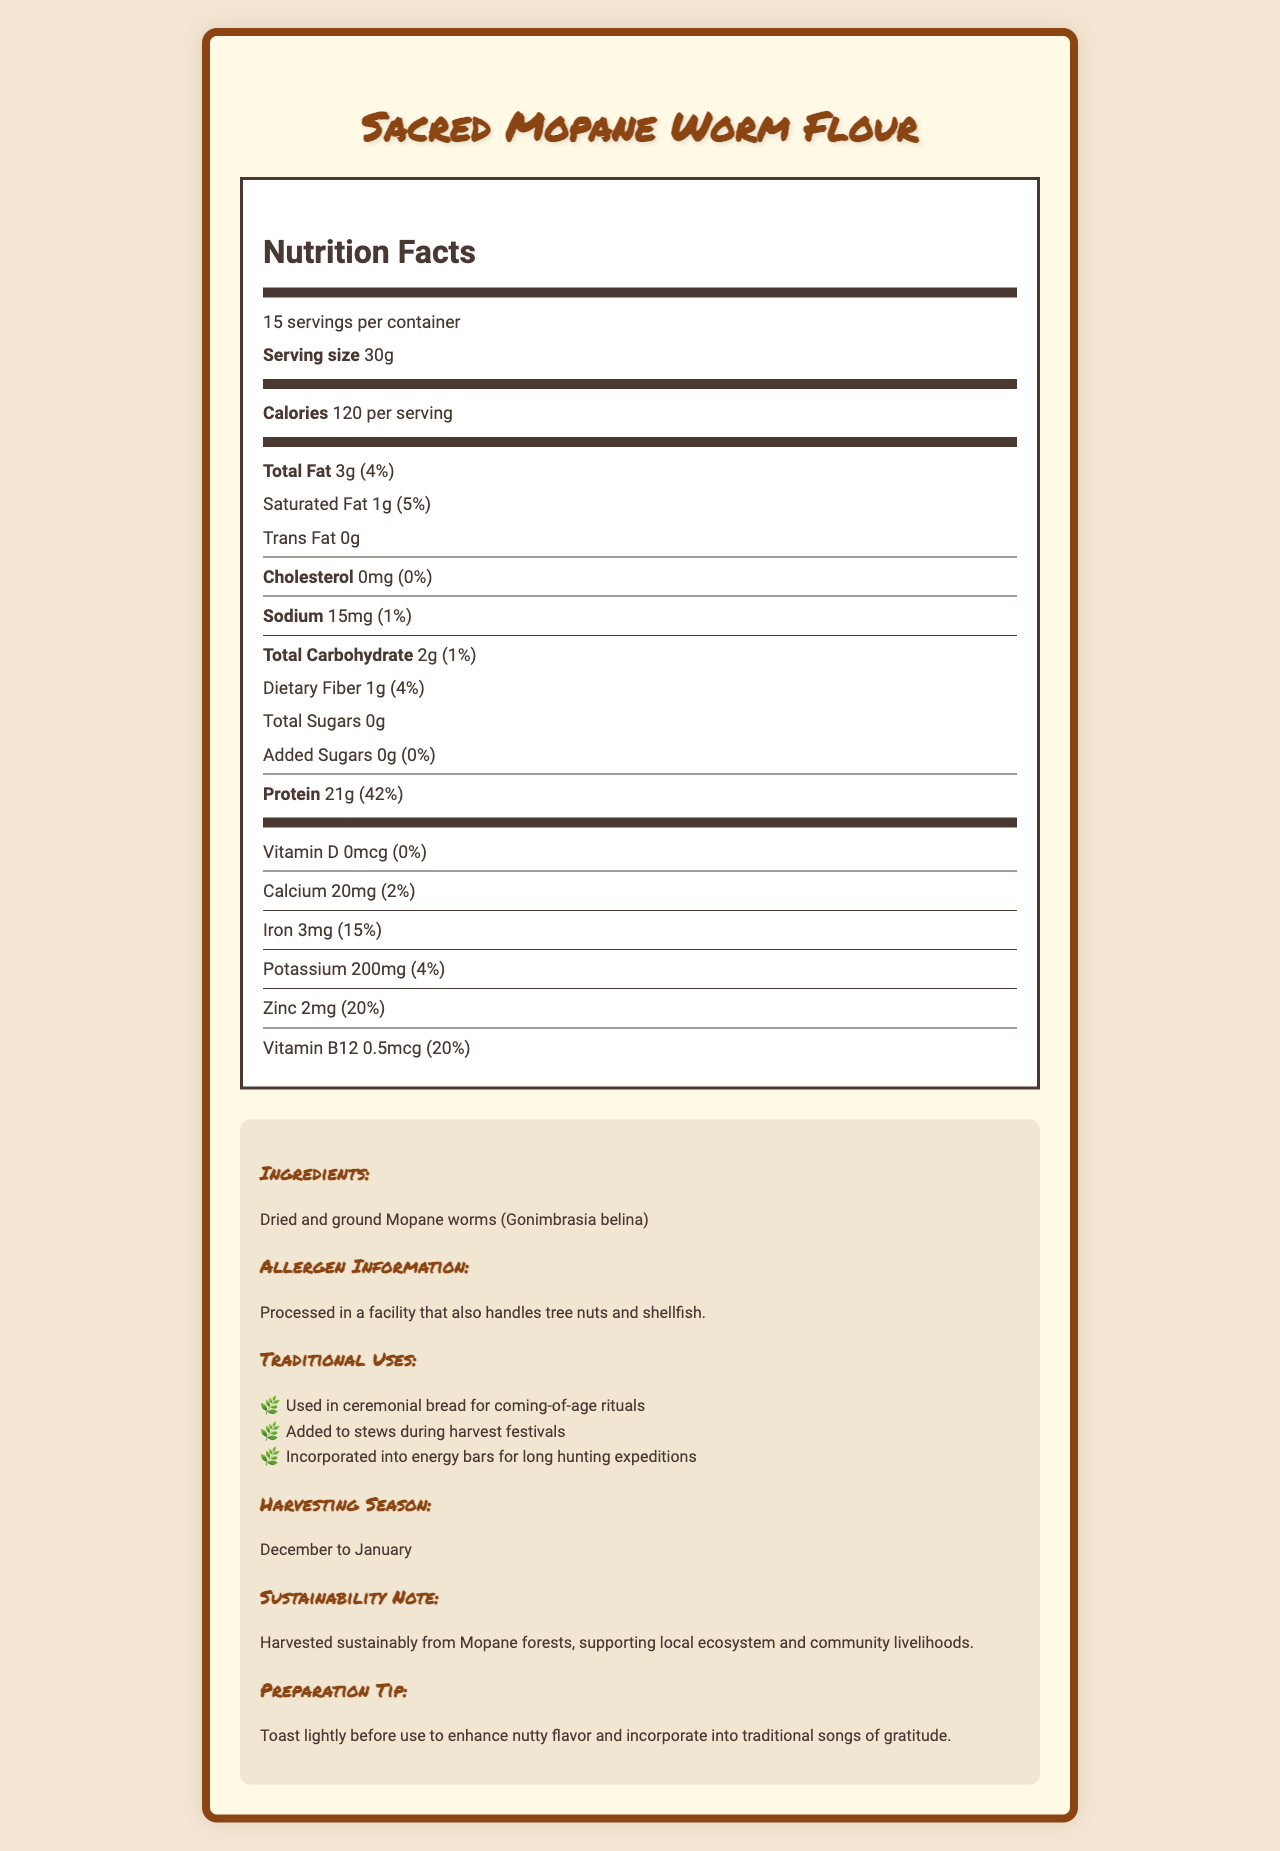what is the serving size of Sacred Mopane Worm Flour? The serving size is listed as 30g on the document under the nutrition facts label.
Answer: 30g how many calories are in each serving? The document states that there are 120 calories per serving in the nutrition facts section.
Answer: 120 what percentage of daily protein value does one serving provide? The protein amount per serving is 21g, which is 42% of the daily value according to the nutrition facts.
Answer: 42% how much iron is in a single serving? The nutrition facts label indicates that there are 3mg of iron in a single serving.
Answer: 3mg which ingredient is mentioned in the document? The ingredients section of the document lists "Dried and ground Mopane worms (Gonimbrasia belina)".
Answer: Dried and ground Mopane worms (Gonimbrasia belina) how much sodium does one serving of the product contain? A. 10mg B. 15mg C. 20mg D. 25mg The nutrition facts section shows that one serving contains 15mg of sodium.
Answer: B. 15mg how many servings per container does the Sacred Mopane Worm Flour have? A. 10 B. 12 C. 15 D. 20 The document states that there are 15 servings per container under the nutrition facts.
Answer: C. 15 does the product contain any added sugars? The documentation explicitly mentions that there are 0g of added sugars.
Answer: No is the product processed in a facility that handles allergens? The allergen information section states that it is processed in a facility that also handles tree nuts and shellfish.
Answer: Yes summarize the document in your own words. The document includes all relevant nutritional information, ingredient details, allergen warnings, and cultural and sustainability insights related to Sacred Mopane Worm Flour.
Answer: The document provides a detailed nutrition facts label for Sacred Mopane Worm Flour, listing serving size, calories, fats, cholesterol, sodium, carbohydrates, proteins, vitamins, and minerals. It also includes ingredient details, allergen information, traditional uses, harvesting season, sustainability notes, and preparation tips. how is the product traditionally used? The extra information section describes the traditional uses of Sacred Mopane Worm Flour.
Answer: Used in ceremonial bread for coming-of-age rituals, added to stews during harvest festivals, and incorporated into energy bars for long hunting expeditions. what season is the product harvested? The document states under the harvesting season that Sacred Mopane Worm Flour is harvested from December to January.
Answer: December to January does Sacred Mopane Worm Flour have any trans fat? The nutrition facts section specifies that the product contains 0g of trans fat.
Answer: No what enhances the nutty flavor during preparation? The preparation tip advises toasting the flour lightly to enhance its nutty flavor.
Answer: Toasting lightly which vitamin does the product contain that contributes 20% to the daily value? A. Vitamin D B. Vitamin B12 C. Vitamin C D. Vitamin A The nutrition facts section shows that Vitamin B12 amounts to 0.5mcg, which is 20% of the daily value.
Answer: B. Vitamin B12 can the exact year of the product's origin be determined from the document? The document does not provide any specific details about the year of origin.
Answer: Not enough information 